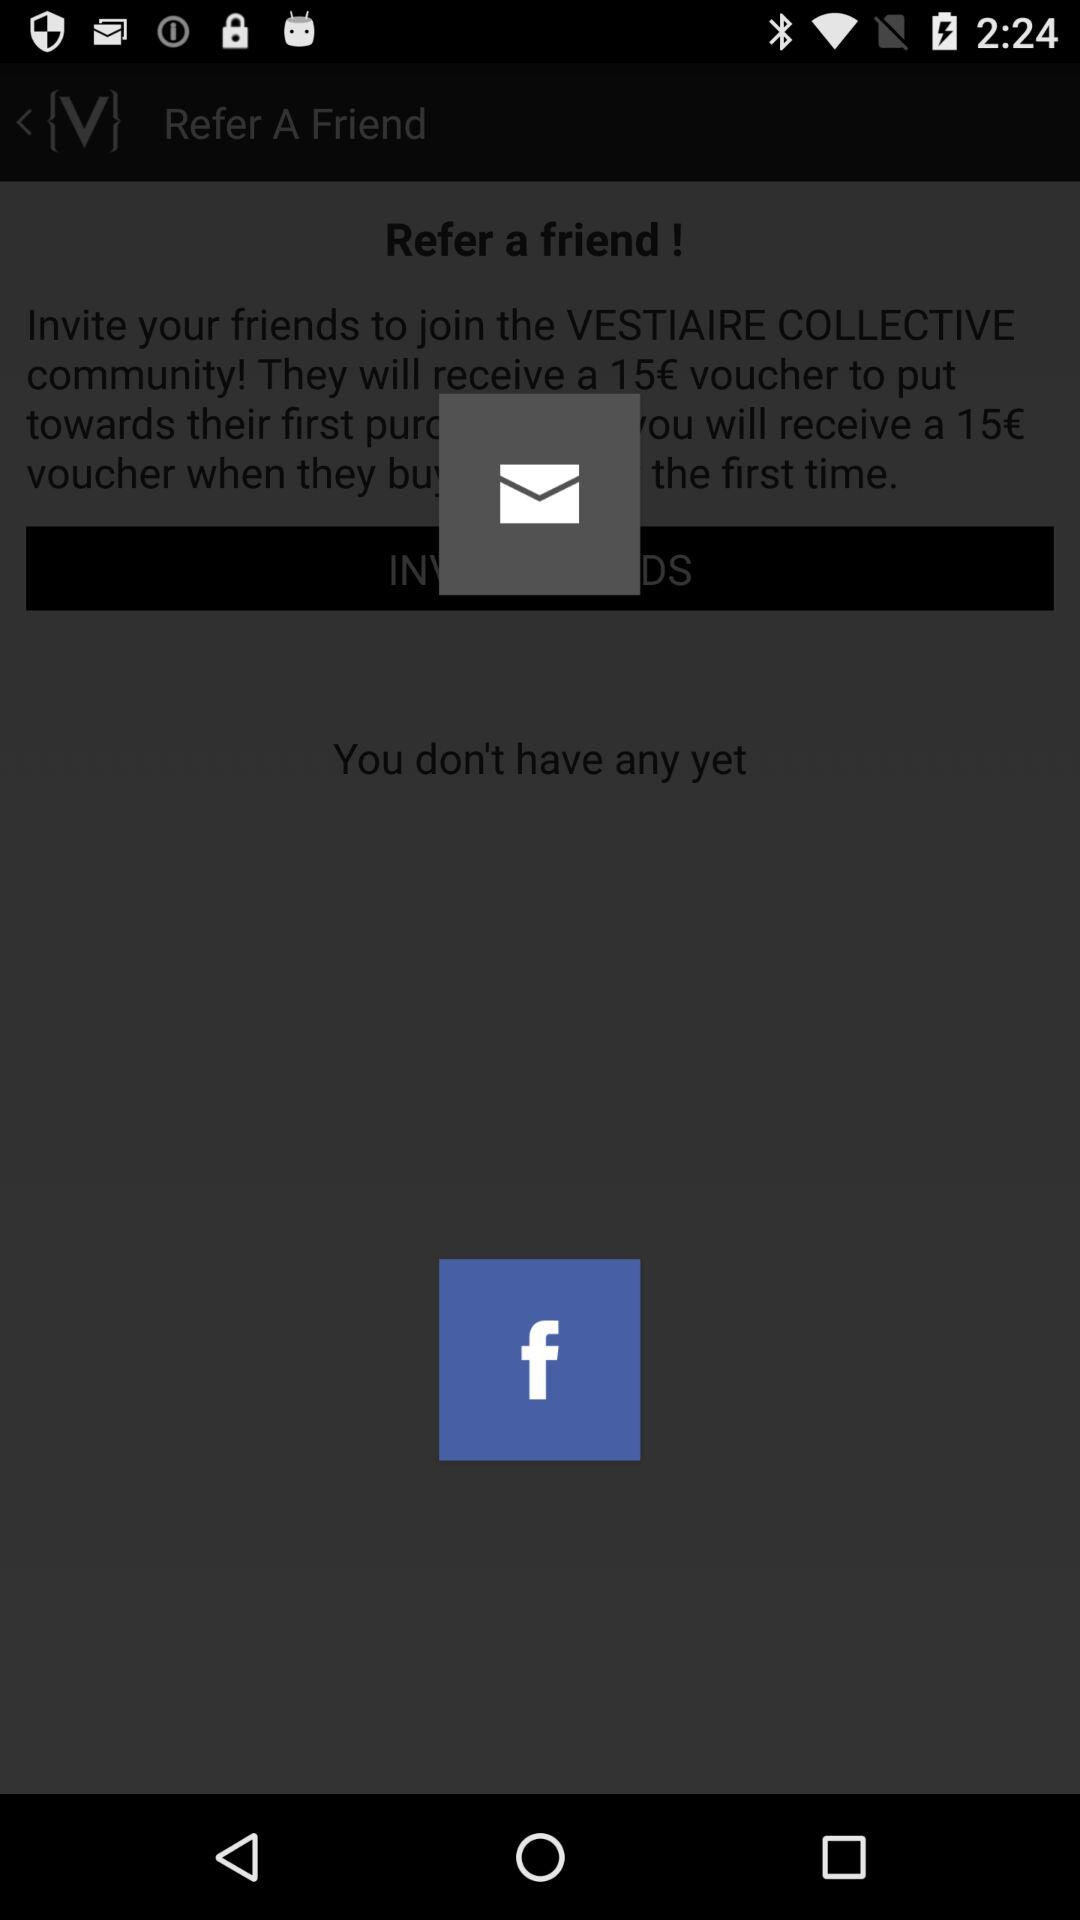How many vouchers have I received?
Answer the question using a single word or phrase. 0 